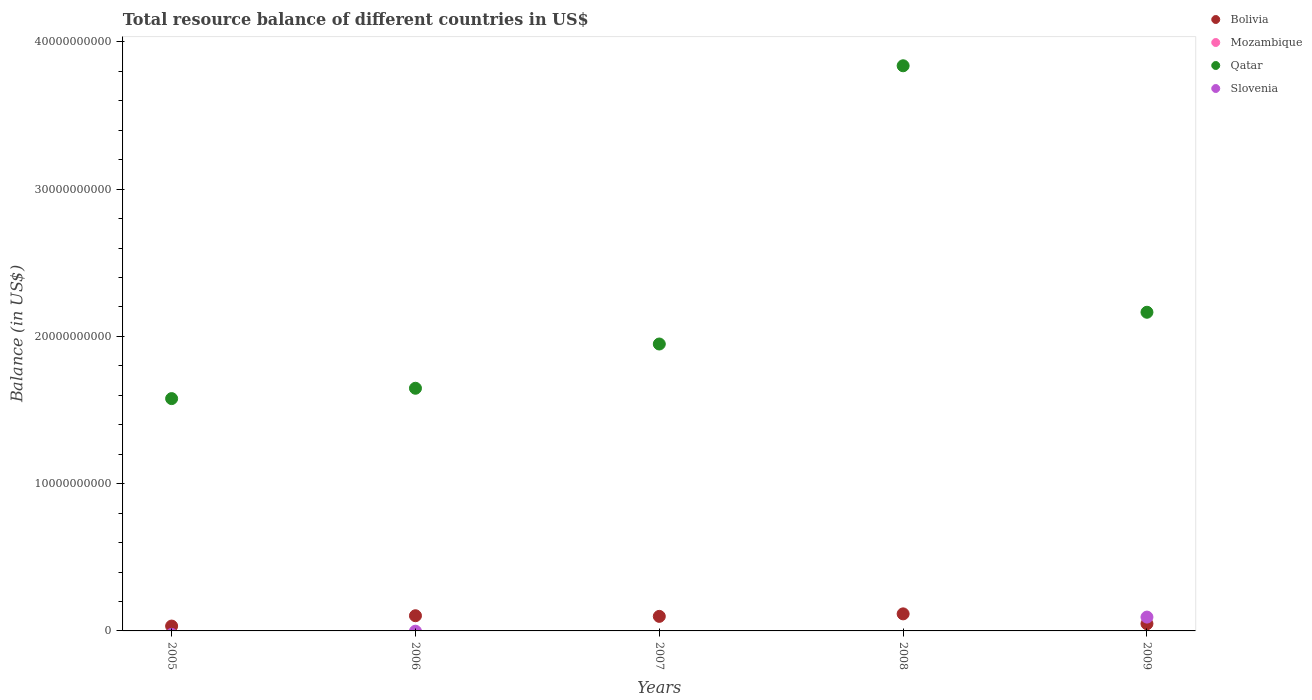How many different coloured dotlines are there?
Keep it short and to the point. 3. What is the total resource balance in Qatar in 2008?
Provide a succinct answer. 3.84e+1. Across all years, what is the maximum total resource balance in Bolivia?
Your response must be concise. 1.16e+09. Across all years, what is the minimum total resource balance in Slovenia?
Your answer should be very brief. 0. In which year was the total resource balance in Bolivia maximum?
Your answer should be very brief. 2008. What is the total total resource balance in Slovenia in the graph?
Offer a terse response. 9.39e+08. What is the difference between the total resource balance in Qatar in 2005 and that in 2006?
Offer a very short reply. -7.03e+08. What is the difference between the total resource balance in Qatar in 2005 and the total resource balance in Bolivia in 2008?
Your answer should be very brief. 1.46e+1. In the year 2007, what is the difference between the total resource balance in Qatar and total resource balance in Bolivia?
Provide a succinct answer. 1.85e+1. What is the ratio of the total resource balance in Qatar in 2005 to that in 2009?
Make the answer very short. 0.73. Is the difference between the total resource balance in Qatar in 2005 and 2007 greater than the difference between the total resource balance in Bolivia in 2005 and 2007?
Make the answer very short. No. What is the difference between the highest and the second highest total resource balance in Qatar?
Make the answer very short. 1.67e+1. What is the difference between the highest and the lowest total resource balance in Qatar?
Make the answer very short. 2.26e+1. Is the sum of the total resource balance in Bolivia in 2006 and 2009 greater than the maximum total resource balance in Mozambique across all years?
Provide a succinct answer. Yes. Is it the case that in every year, the sum of the total resource balance in Slovenia and total resource balance in Qatar  is greater than the total resource balance in Bolivia?
Ensure brevity in your answer.  Yes. Does the total resource balance in Qatar monotonically increase over the years?
Keep it short and to the point. No. How many dotlines are there?
Give a very brief answer. 3. How many years are there in the graph?
Your answer should be compact. 5. Does the graph contain grids?
Your response must be concise. No. Where does the legend appear in the graph?
Your response must be concise. Top right. How many legend labels are there?
Your response must be concise. 4. What is the title of the graph?
Offer a terse response. Total resource balance of different countries in US$. Does "Pacific island small states" appear as one of the legend labels in the graph?
Give a very brief answer. No. What is the label or title of the Y-axis?
Offer a very short reply. Balance (in US$). What is the Balance (in US$) of Bolivia in 2005?
Ensure brevity in your answer.  3.30e+08. What is the Balance (in US$) of Qatar in 2005?
Give a very brief answer. 1.58e+1. What is the Balance (in US$) of Slovenia in 2005?
Offer a terse response. 0. What is the Balance (in US$) in Bolivia in 2006?
Provide a short and direct response. 1.03e+09. What is the Balance (in US$) in Mozambique in 2006?
Your answer should be compact. 0. What is the Balance (in US$) of Qatar in 2006?
Keep it short and to the point. 1.65e+1. What is the Balance (in US$) in Slovenia in 2006?
Provide a short and direct response. 0. What is the Balance (in US$) in Bolivia in 2007?
Offer a very short reply. 9.88e+08. What is the Balance (in US$) of Mozambique in 2007?
Your response must be concise. 0. What is the Balance (in US$) in Qatar in 2007?
Provide a short and direct response. 1.95e+1. What is the Balance (in US$) in Bolivia in 2008?
Offer a terse response. 1.16e+09. What is the Balance (in US$) in Qatar in 2008?
Offer a terse response. 3.84e+1. What is the Balance (in US$) of Slovenia in 2008?
Your answer should be very brief. 0. What is the Balance (in US$) of Bolivia in 2009?
Provide a short and direct response. 4.89e+08. What is the Balance (in US$) in Qatar in 2009?
Ensure brevity in your answer.  2.16e+1. What is the Balance (in US$) in Slovenia in 2009?
Provide a short and direct response. 9.39e+08. Across all years, what is the maximum Balance (in US$) of Bolivia?
Provide a short and direct response. 1.16e+09. Across all years, what is the maximum Balance (in US$) of Qatar?
Keep it short and to the point. 3.84e+1. Across all years, what is the maximum Balance (in US$) of Slovenia?
Offer a very short reply. 9.39e+08. Across all years, what is the minimum Balance (in US$) of Bolivia?
Ensure brevity in your answer.  3.30e+08. Across all years, what is the minimum Balance (in US$) of Qatar?
Ensure brevity in your answer.  1.58e+1. What is the total Balance (in US$) of Bolivia in the graph?
Make the answer very short. 4.00e+09. What is the total Balance (in US$) in Qatar in the graph?
Offer a terse response. 1.12e+11. What is the total Balance (in US$) of Slovenia in the graph?
Offer a terse response. 9.39e+08. What is the difference between the Balance (in US$) in Bolivia in 2005 and that in 2006?
Give a very brief answer. -7.01e+08. What is the difference between the Balance (in US$) of Qatar in 2005 and that in 2006?
Provide a succinct answer. -7.03e+08. What is the difference between the Balance (in US$) in Bolivia in 2005 and that in 2007?
Make the answer very short. -6.58e+08. What is the difference between the Balance (in US$) in Qatar in 2005 and that in 2007?
Your answer should be compact. -3.71e+09. What is the difference between the Balance (in US$) in Bolivia in 2005 and that in 2008?
Your response must be concise. -8.28e+08. What is the difference between the Balance (in US$) of Qatar in 2005 and that in 2008?
Your answer should be very brief. -2.26e+1. What is the difference between the Balance (in US$) of Bolivia in 2005 and that in 2009?
Provide a succinct answer. -1.59e+08. What is the difference between the Balance (in US$) of Qatar in 2005 and that in 2009?
Provide a short and direct response. -5.86e+09. What is the difference between the Balance (in US$) of Bolivia in 2006 and that in 2007?
Provide a succinct answer. 4.34e+07. What is the difference between the Balance (in US$) in Qatar in 2006 and that in 2007?
Your response must be concise. -3.00e+09. What is the difference between the Balance (in US$) in Bolivia in 2006 and that in 2008?
Keep it short and to the point. -1.27e+08. What is the difference between the Balance (in US$) of Qatar in 2006 and that in 2008?
Provide a succinct answer. -2.19e+1. What is the difference between the Balance (in US$) in Bolivia in 2006 and that in 2009?
Keep it short and to the point. 5.43e+08. What is the difference between the Balance (in US$) in Qatar in 2006 and that in 2009?
Keep it short and to the point. -5.16e+09. What is the difference between the Balance (in US$) in Bolivia in 2007 and that in 2008?
Offer a very short reply. -1.70e+08. What is the difference between the Balance (in US$) of Qatar in 2007 and that in 2008?
Ensure brevity in your answer.  -1.89e+1. What is the difference between the Balance (in US$) of Bolivia in 2007 and that in 2009?
Ensure brevity in your answer.  4.99e+08. What is the difference between the Balance (in US$) of Qatar in 2007 and that in 2009?
Make the answer very short. -2.16e+09. What is the difference between the Balance (in US$) of Bolivia in 2008 and that in 2009?
Provide a short and direct response. 6.70e+08. What is the difference between the Balance (in US$) in Qatar in 2008 and that in 2009?
Your response must be concise. 1.67e+1. What is the difference between the Balance (in US$) in Bolivia in 2005 and the Balance (in US$) in Qatar in 2006?
Provide a succinct answer. -1.61e+1. What is the difference between the Balance (in US$) of Bolivia in 2005 and the Balance (in US$) of Qatar in 2007?
Give a very brief answer. -1.92e+1. What is the difference between the Balance (in US$) of Bolivia in 2005 and the Balance (in US$) of Qatar in 2008?
Keep it short and to the point. -3.80e+1. What is the difference between the Balance (in US$) of Bolivia in 2005 and the Balance (in US$) of Qatar in 2009?
Keep it short and to the point. -2.13e+1. What is the difference between the Balance (in US$) of Bolivia in 2005 and the Balance (in US$) of Slovenia in 2009?
Provide a succinct answer. -6.09e+08. What is the difference between the Balance (in US$) of Qatar in 2005 and the Balance (in US$) of Slovenia in 2009?
Your answer should be very brief. 1.48e+1. What is the difference between the Balance (in US$) in Bolivia in 2006 and the Balance (in US$) in Qatar in 2007?
Ensure brevity in your answer.  -1.85e+1. What is the difference between the Balance (in US$) in Bolivia in 2006 and the Balance (in US$) in Qatar in 2008?
Your answer should be compact. -3.73e+1. What is the difference between the Balance (in US$) of Bolivia in 2006 and the Balance (in US$) of Qatar in 2009?
Offer a very short reply. -2.06e+1. What is the difference between the Balance (in US$) of Bolivia in 2006 and the Balance (in US$) of Slovenia in 2009?
Your answer should be very brief. 9.23e+07. What is the difference between the Balance (in US$) of Qatar in 2006 and the Balance (in US$) of Slovenia in 2009?
Make the answer very short. 1.55e+1. What is the difference between the Balance (in US$) in Bolivia in 2007 and the Balance (in US$) in Qatar in 2008?
Provide a short and direct response. -3.74e+1. What is the difference between the Balance (in US$) in Bolivia in 2007 and the Balance (in US$) in Qatar in 2009?
Your answer should be very brief. -2.07e+1. What is the difference between the Balance (in US$) of Bolivia in 2007 and the Balance (in US$) of Slovenia in 2009?
Ensure brevity in your answer.  4.89e+07. What is the difference between the Balance (in US$) in Qatar in 2007 and the Balance (in US$) in Slovenia in 2009?
Keep it short and to the point. 1.85e+1. What is the difference between the Balance (in US$) of Bolivia in 2008 and the Balance (in US$) of Qatar in 2009?
Your answer should be compact. -2.05e+1. What is the difference between the Balance (in US$) of Bolivia in 2008 and the Balance (in US$) of Slovenia in 2009?
Your answer should be very brief. 2.19e+08. What is the difference between the Balance (in US$) of Qatar in 2008 and the Balance (in US$) of Slovenia in 2009?
Ensure brevity in your answer.  3.74e+1. What is the average Balance (in US$) in Bolivia per year?
Make the answer very short. 7.99e+08. What is the average Balance (in US$) in Qatar per year?
Offer a terse response. 2.23e+1. What is the average Balance (in US$) in Slovenia per year?
Offer a very short reply. 1.88e+08. In the year 2005, what is the difference between the Balance (in US$) of Bolivia and Balance (in US$) of Qatar?
Make the answer very short. -1.54e+1. In the year 2006, what is the difference between the Balance (in US$) in Bolivia and Balance (in US$) in Qatar?
Your response must be concise. -1.54e+1. In the year 2007, what is the difference between the Balance (in US$) of Bolivia and Balance (in US$) of Qatar?
Provide a succinct answer. -1.85e+1. In the year 2008, what is the difference between the Balance (in US$) in Bolivia and Balance (in US$) in Qatar?
Your response must be concise. -3.72e+1. In the year 2009, what is the difference between the Balance (in US$) in Bolivia and Balance (in US$) in Qatar?
Offer a terse response. -2.11e+1. In the year 2009, what is the difference between the Balance (in US$) of Bolivia and Balance (in US$) of Slovenia?
Provide a short and direct response. -4.50e+08. In the year 2009, what is the difference between the Balance (in US$) in Qatar and Balance (in US$) in Slovenia?
Make the answer very short. 2.07e+1. What is the ratio of the Balance (in US$) of Bolivia in 2005 to that in 2006?
Make the answer very short. 0.32. What is the ratio of the Balance (in US$) in Qatar in 2005 to that in 2006?
Offer a terse response. 0.96. What is the ratio of the Balance (in US$) of Bolivia in 2005 to that in 2007?
Offer a very short reply. 0.33. What is the ratio of the Balance (in US$) in Qatar in 2005 to that in 2007?
Provide a succinct answer. 0.81. What is the ratio of the Balance (in US$) of Bolivia in 2005 to that in 2008?
Offer a terse response. 0.28. What is the ratio of the Balance (in US$) of Qatar in 2005 to that in 2008?
Make the answer very short. 0.41. What is the ratio of the Balance (in US$) of Bolivia in 2005 to that in 2009?
Provide a succinct answer. 0.68. What is the ratio of the Balance (in US$) of Qatar in 2005 to that in 2009?
Your response must be concise. 0.73. What is the ratio of the Balance (in US$) in Bolivia in 2006 to that in 2007?
Your answer should be compact. 1.04. What is the ratio of the Balance (in US$) in Qatar in 2006 to that in 2007?
Give a very brief answer. 0.85. What is the ratio of the Balance (in US$) of Bolivia in 2006 to that in 2008?
Offer a terse response. 0.89. What is the ratio of the Balance (in US$) of Qatar in 2006 to that in 2008?
Provide a succinct answer. 0.43. What is the ratio of the Balance (in US$) in Bolivia in 2006 to that in 2009?
Ensure brevity in your answer.  2.11. What is the ratio of the Balance (in US$) in Qatar in 2006 to that in 2009?
Give a very brief answer. 0.76. What is the ratio of the Balance (in US$) in Bolivia in 2007 to that in 2008?
Provide a short and direct response. 0.85. What is the ratio of the Balance (in US$) in Qatar in 2007 to that in 2008?
Provide a succinct answer. 0.51. What is the ratio of the Balance (in US$) of Bolivia in 2007 to that in 2009?
Give a very brief answer. 2.02. What is the ratio of the Balance (in US$) in Qatar in 2007 to that in 2009?
Offer a terse response. 0.9. What is the ratio of the Balance (in US$) of Bolivia in 2008 to that in 2009?
Provide a succinct answer. 2.37. What is the ratio of the Balance (in US$) in Qatar in 2008 to that in 2009?
Provide a short and direct response. 1.77. What is the difference between the highest and the second highest Balance (in US$) of Bolivia?
Make the answer very short. 1.27e+08. What is the difference between the highest and the second highest Balance (in US$) of Qatar?
Ensure brevity in your answer.  1.67e+1. What is the difference between the highest and the lowest Balance (in US$) of Bolivia?
Provide a succinct answer. 8.28e+08. What is the difference between the highest and the lowest Balance (in US$) in Qatar?
Offer a terse response. 2.26e+1. What is the difference between the highest and the lowest Balance (in US$) in Slovenia?
Ensure brevity in your answer.  9.39e+08. 